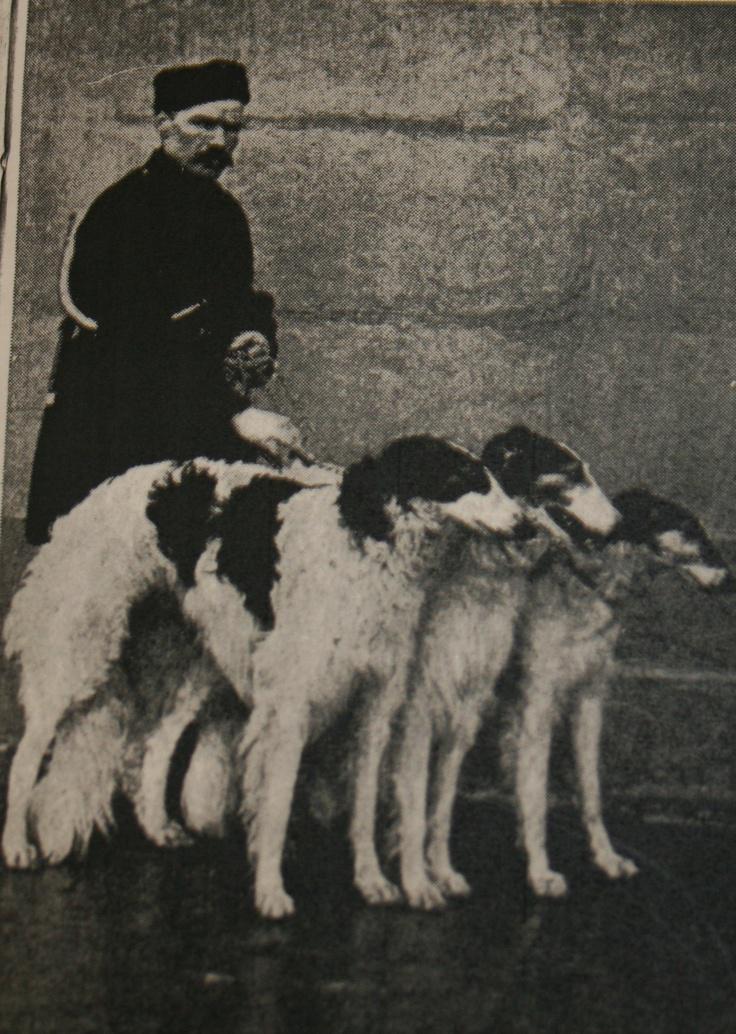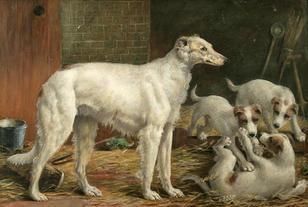The first image is the image on the left, the second image is the image on the right. Analyze the images presented: Is the assertion "The right image shows a woman in a long dress, standing behind an afghan hound, with flowers held in one hand." valid? Answer yes or no. No. The first image is the image on the left, the second image is the image on the right. Considering the images on both sides, is "A woman is standing with a single dog in the image on the right." valid? Answer yes or no. No. 